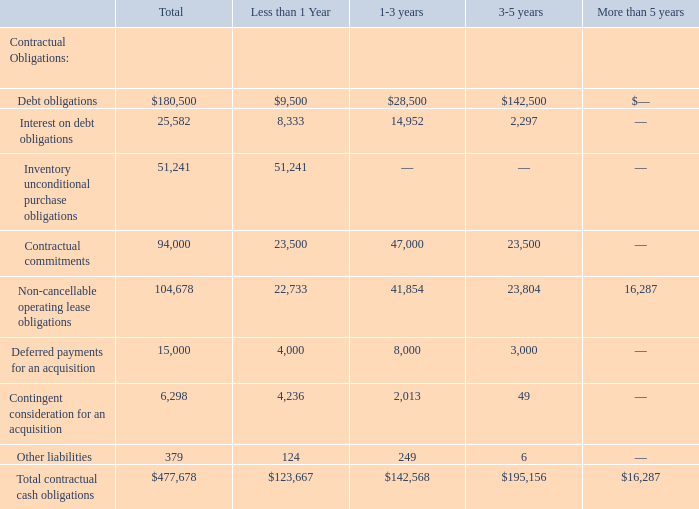Contractual Obligations
The following summarizes our contractual obligations at June 30, 2019, and the effect such obligations are expected to have on our liquidity and cash flow in future periods (in thousands):
The contractual obligations referenced above are more specifically defined as follows:
Debt obligations relate to amounts owed under our Credit Agreement.
Inventory unconditional purchase obligations represent the purchase of long lead-time component inventory that our contract manufacturers procure in accordance with our forecast. We expect to honor the inventory purchase commitments within the next 12 months.
Contractual commitments to suppliers for future services.
Deferred payments represent Data Center Business consideration obligation of $1.0 million per quarter.
Contingent consideration for the Capital Financing Business acquisition, at fair value. Actual payments could be different
Non-cancelable operating lease obligations represent base rents and operating expense obligations.
Other liabilities include our commitments towards debt related fees and specific arrangements other than inventory.
The amounts in the table above exclude immaterial income tax liabilities related to uncertain tax positions as we are unable to reasonably estimate the timing of the settlement.
We did not have any material commitments for capital expenditures as of June 30, 2019.
What did Debt obligations relate to? Amounts owed under our credit agreement. What does Inventory unconditional purchase obligations represent? The purchase of long lead-time component inventory that our contract manufacturers procure in accordance with our forecast. What was the total amount of interest on debt obligations?
Answer scale should be: thousand. 25,582. How many types of contractual obligations had a total that exceeded $100,000 thousand? Debt obligations##Non-cancellable operating lease obligations
Answer: 2. What was the difference in the total between Contractual commitments and Inventory unconditional purchase obligations?
Answer scale should be: thousand. 94,000-51,241
Answer: 42759. What was the difference in the total between Deferred payments for an acquisition and Contingent consideration for an acquisition?
Answer scale should be: thousand. 15,000-6,298
Answer: 8702. 